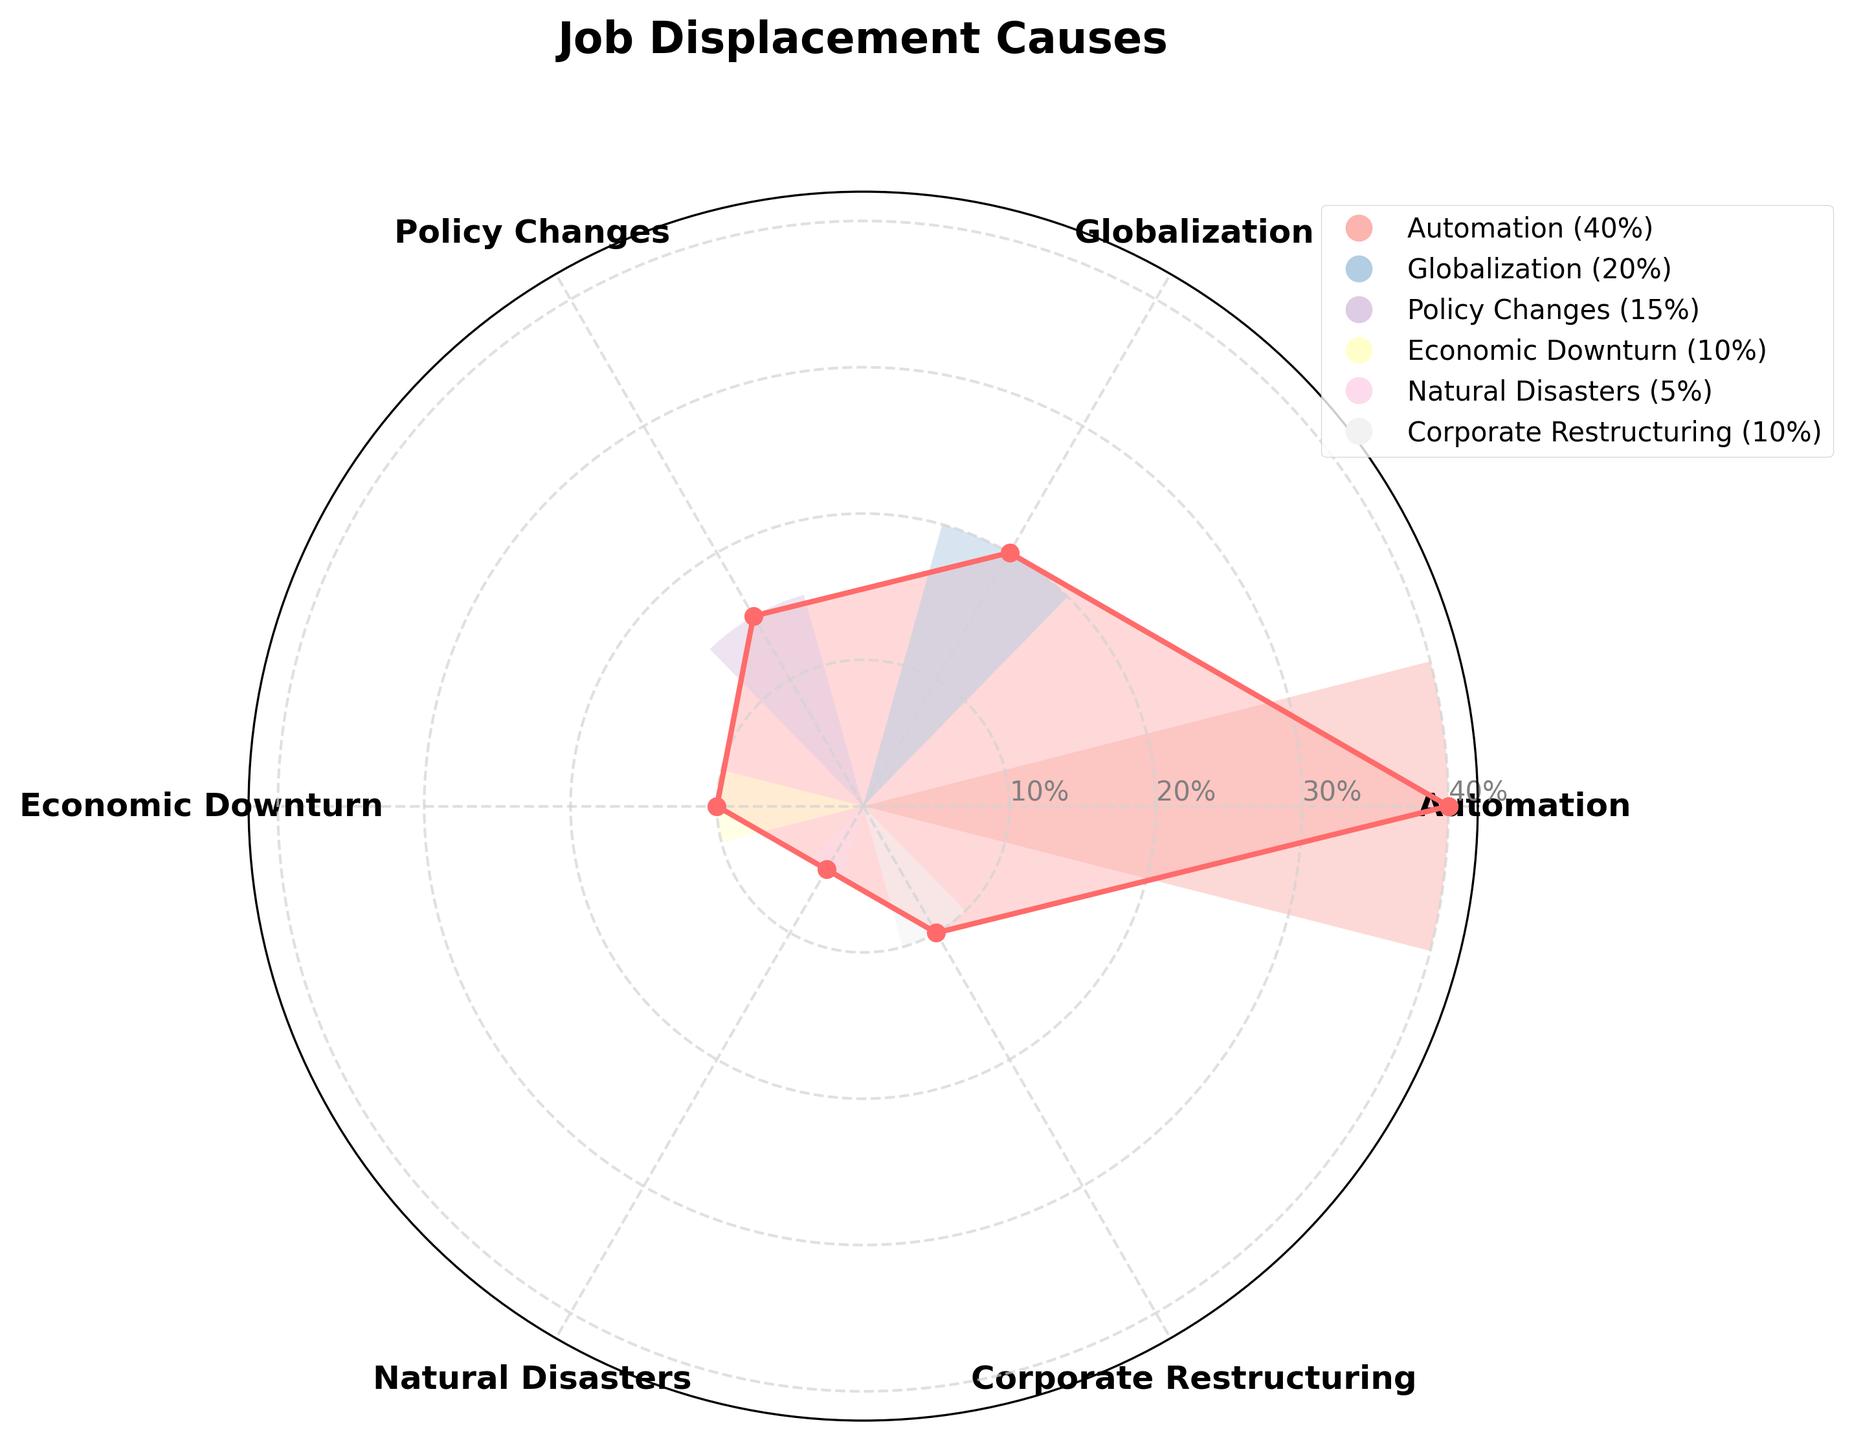How many categories are represented in the plot? Count the labeled sections around the polar chart.
Answer: 6 What is the title of the plot? Read the text centered at the top of the figure.
Answer: Job Displacement Causes Which cause has the highest proportion of job displacement? Identify the category with the largest section in the chart.
Answer: Automation What's the proportion of job displacement caused by policy changes and economic downturn combined? Add the proportions of Policy Changes (15%) and Economic Downturn (10%).
Answer: 25% Which two causes have equal proportions of job displacement? Compare the size of the sections and look for those with the same proportion; both are labeled.
Answer: Economic Downturn, Corporate Restructuring How does the proportion of job displacement due to globalization compare to that caused by corporate restructuring? Compare the sections labeled Globalization (20%) and Corporate Restructuring (10%).
Answer: Globalization is double Corporate Restructuring's Which category accounts for the smallest proportion of job displacement? Identify the category with the smallest section in the chart.
Answer: Natural Disasters What is the combined proportion of job displacement due to non-automation causes? Sum the proportions of all categories except Automation (Globalization 20%, Policy Changes 15%, Economic Downturn 10%, Natural Disasters 5%, Corporate Restructuring 10%).
Answer: 60% By how much does the proportion of job displacement due to automation exceed that due to policy changes? Subtract the proportion of Policy Changes (15%) from the proportion of Automation (40%).
Answer: 25% What is the main cause of job displacement according to the chart? Identify the category with the highest proportion.
Answer: Automation 